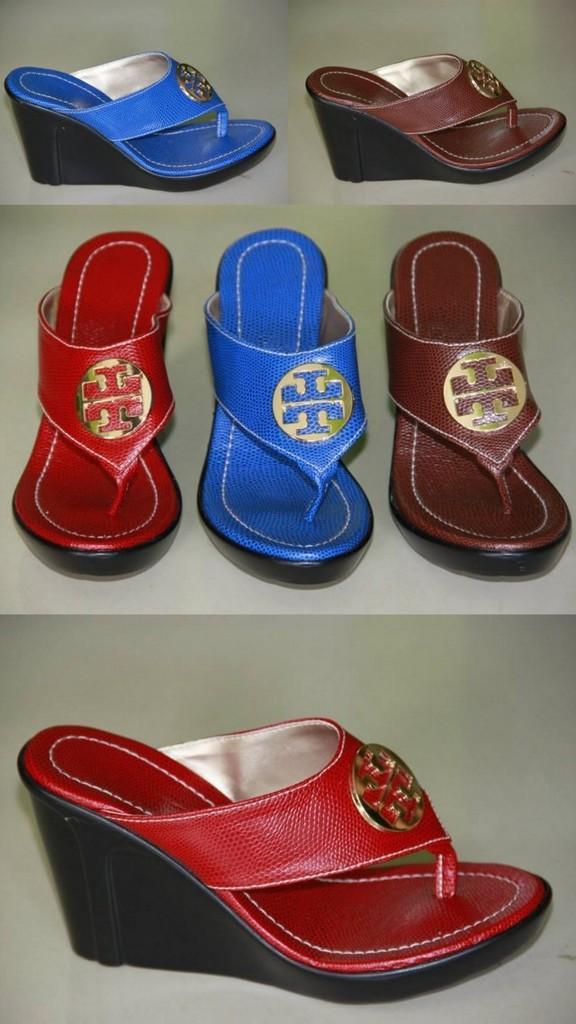In one or two sentences, can you explain what this image depicts? In this picture we can see footwear. 